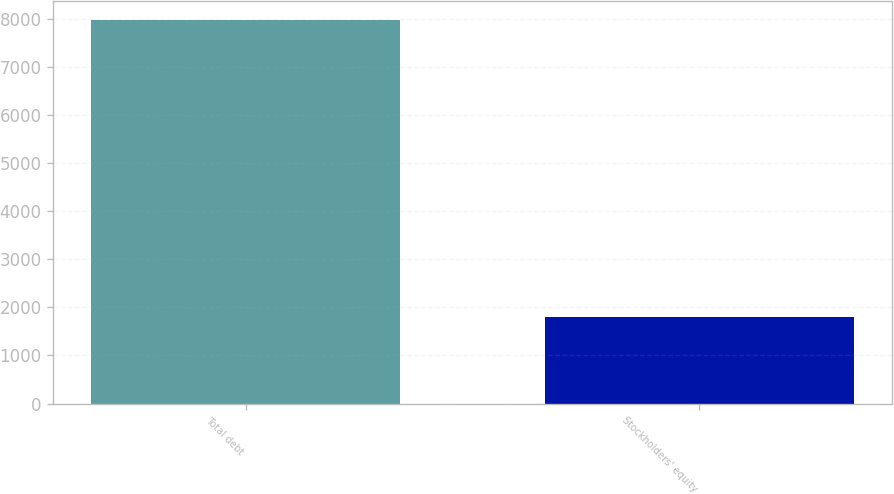<chart> <loc_0><loc_0><loc_500><loc_500><bar_chart><fcel>Total debt<fcel>Stockholders' equity<nl><fcel>7962<fcel>1796<nl></chart> 